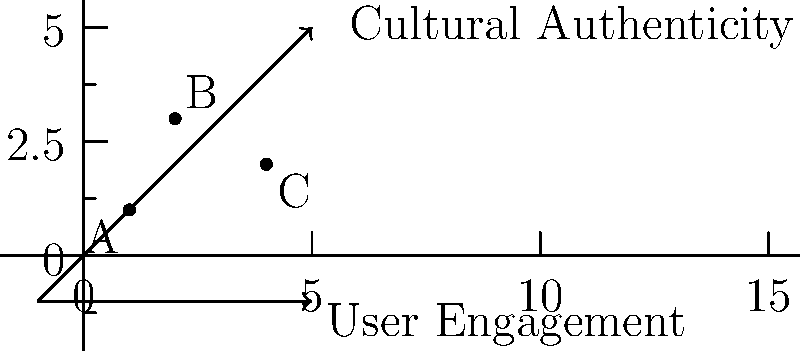In designing a mobile app interface for learning tribal vocabulary using icons and images, consider the graph where the x-axis represents user engagement and the y-axis represents cultural authenticity. Points A, B, and C represent different design approaches. Which point likely represents the most effective design for a tech-savvy teenager aiming to preserve and promote tribal language, and why? To determine the most effective design approach, we need to consider both user engagement and cultural authenticity:

1. Point A (1,1): Low user engagement and low cultural authenticity.
2. Point B (2,3): Moderate user engagement and high cultural authenticity.
3. Point C (4,2): High user engagement and moderate cultural authenticity.

Step-by-step analysis:
1. User Engagement: As a tech-savvy teenager, high engagement is crucial. This favors point C.
2. Cultural Authenticity: For preserving and promoting tribal language, authenticity is important. This favors point B.
3. Balance: The ideal solution should balance both factors.
4. Target Audience: Teenagers are more likely to use and learn from an app that's engaging.
5. Long-term Impact: Higher engagement can lead to more consistent use and better language preservation.
6. Adaptability: A highly engaging app (C) can be iteratively improved to increase cultural authenticity.
7. Promotion: An engaging app is more likely to be shared among peers, promoting wider use.

Considering these factors, point C (4,2) represents the most effective design. It offers high user engagement, which is crucial for the target audience, while still maintaining a moderate level of cultural authenticity. This approach is more likely to attract and retain teenage users, ultimately contributing more effectively to language preservation and promotion.
Answer: Point C (4,2) 